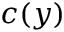Convert formula to latex. <formula><loc_0><loc_0><loc_500><loc_500>c ( y )</formula> 